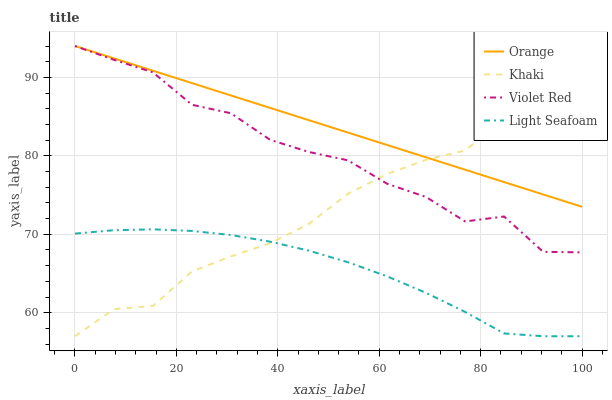Does Violet Red have the minimum area under the curve?
Answer yes or no. No. Does Violet Red have the maximum area under the curve?
Answer yes or no. No. Is Khaki the smoothest?
Answer yes or no. No. Is Khaki the roughest?
Answer yes or no. No. Does Violet Red have the lowest value?
Answer yes or no. No. Does Khaki have the highest value?
Answer yes or no. No. Is Light Seafoam less than Violet Red?
Answer yes or no. Yes. Is Violet Red greater than Light Seafoam?
Answer yes or no. Yes. Does Light Seafoam intersect Violet Red?
Answer yes or no. No. 